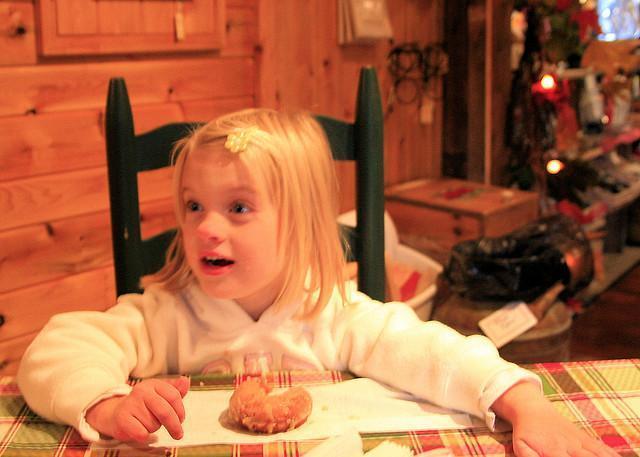How many sandwiches with tomato are there?
Give a very brief answer. 0. 